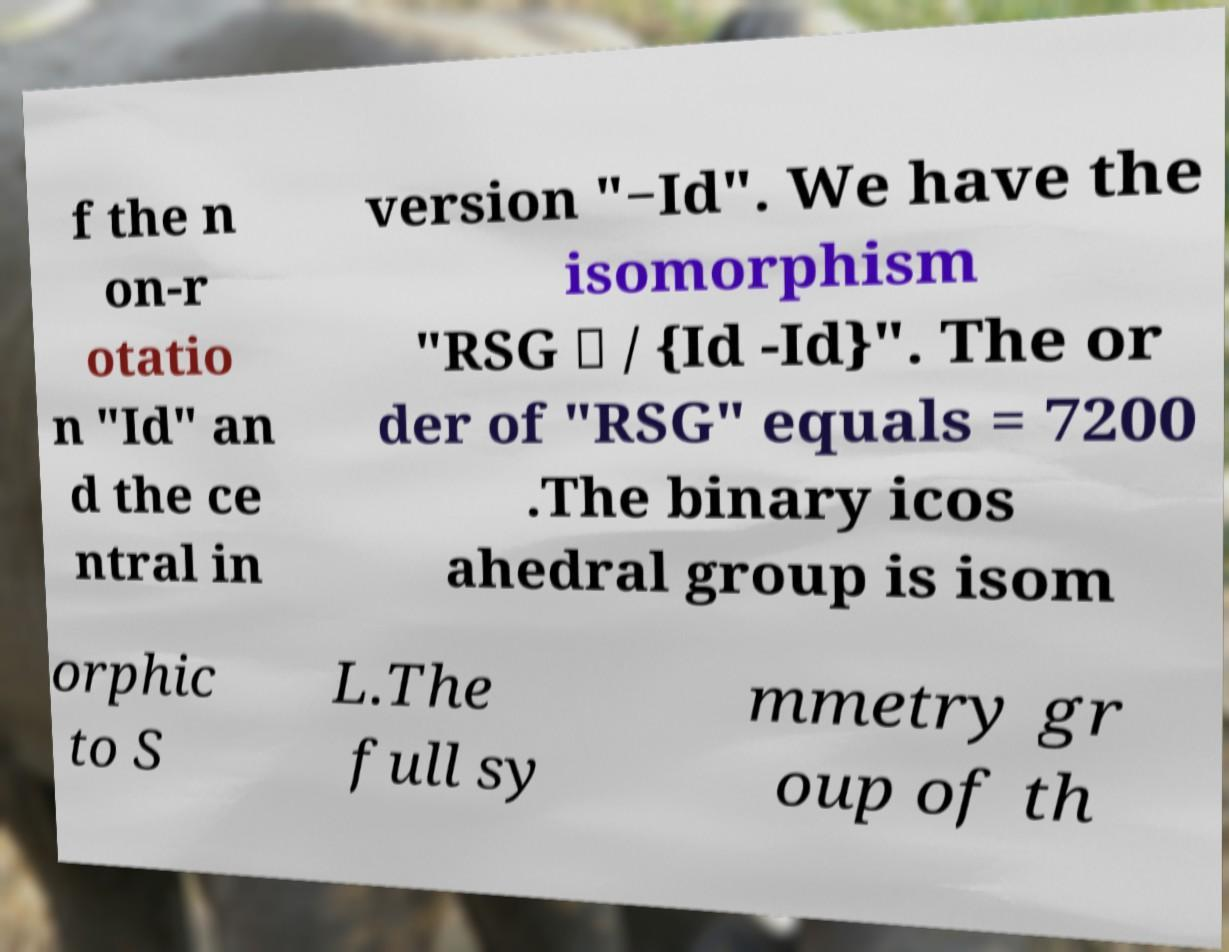For documentation purposes, I need the text within this image transcribed. Could you provide that? f the n on-r otatio n "Id" an d the ce ntral in version "−Id". We have the isomorphism "RSG ≅ / {Id -Id}". The or der of "RSG" equals = 7200 .The binary icos ahedral group is isom orphic to S L.The full sy mmetry gr oup of th 